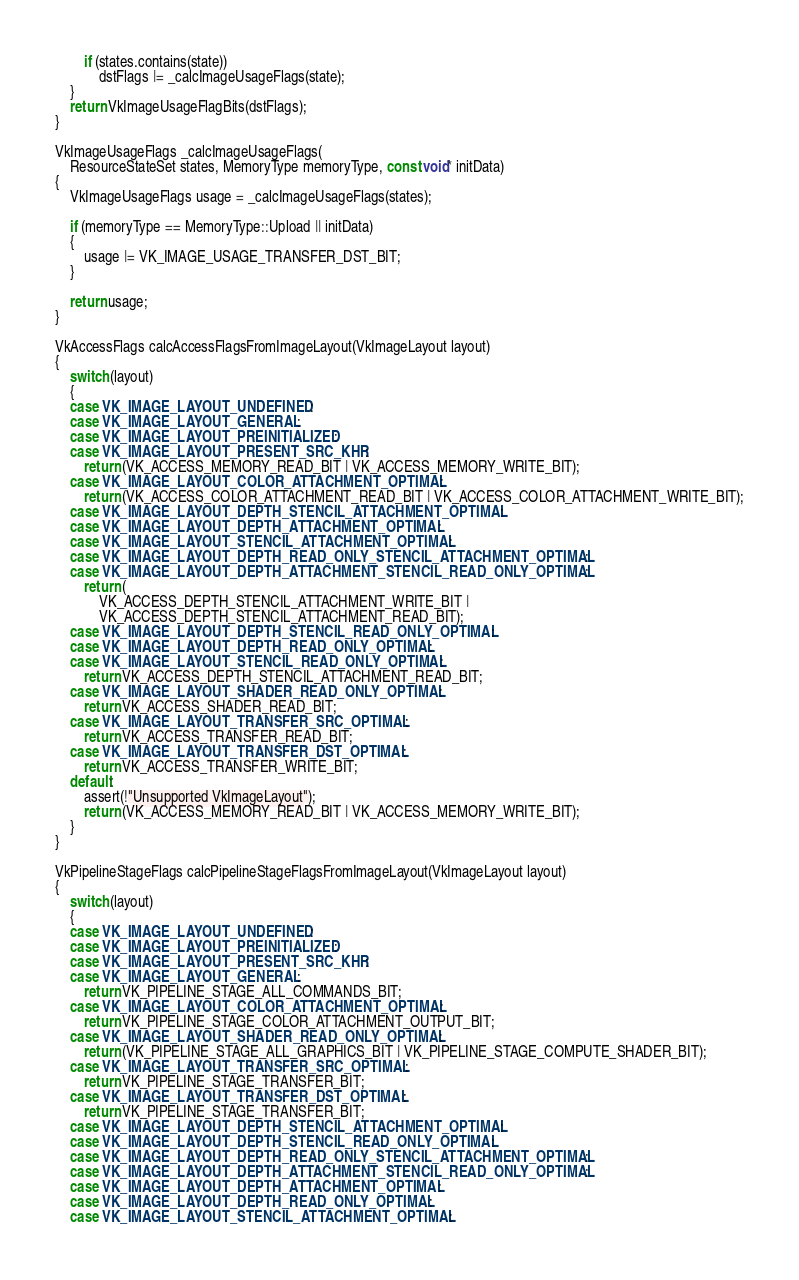<code> <loc_0><loc_0><loc_500><loc_500><_C++_>        if (states.contains(state))
            dstFlags |= _calcImageUsageFlags(state);
    }
    return VkImageUsageFlagBits(dstFlags);
}

VkImageUsageFlags _calcImageUsageFlags(
    ResourceStateSet states, MemoryType memoryType, const void* initData)
{
    VkImageUsageFlags usage = _calcImageUsageFlags(states);

    if (memoryType == MemoryType::Upload || initData)
    {
        usage |= VK_IMAGE_USAGE_TRANSFER_DST_BIT;
    }

    return usage;
}

VkAccessFlags calcAccessFlagsFromImageLayout(VkImageLayout layout)
{
    switch (layout)
    {
    case VK_IMAGE_LAYOUT_UNDEFINED:
    case VK_IMAGE_LAYOUT_GENERAL:
    case VK_IMAGE_LAYOUT_PREINITIALIZED:
    case VK_IMAGE_LAYOUT_PRESENT_SRC_KHR:
        return (VK_ACCESS_MEMORY_READ_BIT | VK_ACCESS_MEMORY_WRITE_BIT);
    case VK_IMAGE_LAYOUT_COLOR_ATTACHMENT_OPTIMAL:
        return (VK_ACCESS_COLOR_ATTACHMENT_READ_BIT | VK_ACCESS_COLOR_ATTACHMENT_WRITE_BIT);
    case VK_IMAGE_LAYOUT_DEPTH_STENCIL_ATTACHMENT_OPTIMAL:
    case VK_IMAGE_LAYOUT_DEPTH_ATTACHMENT_OPTIMAL:
    case VK_IMAGE_LAYOUT_STENCIL_ATTACHMENT_OPTIMAL:
    case VK_IMAGE_LAYOUT_DEPTH_READ_ONLY_STENCIL_ATTACHMENT_OPTIMAL:
    case VK_IMAGE_LAYOUT_DEPTH_ATTACHMENT_STENCIL_READ_ONLY_OPTIMAL:
        return (
            VK_ACCESS_DEPTH_STENCIL_ATTACHMENT_WRITE_BIT |
            VK_ACCESS_DEPTH_STENCIL_ATTACHMENT_READ_BIT);
    case VK_IMAGE_LAYOUT_DEPTH_STENCIL_READ_ONLY_OPTIMAL:
    case VK_IMAGE_LAYOUT_DEPTH_READ_ONLY_OPTIMAL:
    case VK_IMAGE_LAYOUT_STENCIL_READ_ONLY_OPTIMAL:
        return VK_ACCESS_DEPTH_STENCIL_ATTACHMENT_READ_BIT;
    case VK_IMAGE_LAYOUT_SHADER_READ_ONLY_OPTIMAL:
        return VK_ACCESS_SHADER_READ_BIT;
    case VK_IMAGE_LAYOUT_TRANSFER_SRC_OPTIMAL:
        return VK_ACCESS_TRANSFER_READ_BIT;
    case VK_IMAGE_LAYOUT_TRANSFER_DST_OPTIMAL:
        return VK_ACCESS_TRANSFER_WRITE_BIT;
    default:
        assert(!"Unsupported VkImageLayout");
        return (VK_ACCESS_MEMORY_READ_BIT | VK_ACCESS_MEMORY_WRITE_BIT);
    }
}

VkPipelineStageFlags calcPipelineStageFlagsFromImageLayout(VkImageLayout layout)
{
    switch (layout)
    {
    case VK_IMAGE_LAYOUT_UNDEFINED:
    case VK_IMAGE_LAYOUT_PREINITIALIZED:
    case VK_IMAGE_LAYOUT_PRESENT_SRC_KHR:
    case VK_IMAGE_LAYOUT_GENERAL:
        return VK_PIPELINE_STAGE_ALL_COMMANDS_BIT;
    case VK_IMAGE_LAYOUT_COLOR_ATTACHMENT_OPTIMAL:
        return VK_PIPELINE_STAGE_COLOR_ATTACHMENT_OUTPUT_BIT;
    case VK_IMAGE_LAYOUT_SHADER_READ_ONLY_OPTIMAL:
        return (VK_PIPELINE_STAGE_ALL_GRAPHICS_BIT | VK_PIPELINE_STAGE_COMPUTE_SHADER_BIT);
    case VK_IMAGE_LAYOUT_TRANSFER_SRC_OPTIMAL:
        return VK_PIPELINE_STAGE_TRANSFER_BIT;
    case VK_IMAGE_LAYOUT_TRANSFER_DST_OPTIMAL:
        return VK_PIPELINE_STAGE_TRANSFER_BIT;
    case VK_IMAGE_LAYOUT_DEPTH_STENCIL_ATTACHMENT_OPTIMAL:
    case VK_IMAGE_LAYOUT_DEPTH_STENCIL_READ_ONLY_OPTIMAL:
    case VK_IMAGE_LAYOUT_DEPTH_READ_ONLY_STENCIL_ATTACHMENT_OPTIMAL:
    case VK_IMAGE_LAYOUT_DEPTH_ATTACHMENT_STENCIL_READ_ONLY_OPTIMAL:
    case VK_IMAGE_LAYOUT_DEPTH_ATTACHMENT_OPTIMAL:
    case VK_IMAGE_LAYOUT_DEPTH_READ_ONLY_OPTIMAL:
    case VK_IMAGE_LAYOUT_STENCIL_ATTACHMENT_OPTIMAL:</code> 